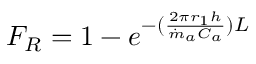Convert formula to latex. <formula><loc_0><loc_0><loc_500><loc_500>\begin{array} { r } { F _ { R } = 1 - e ^ { - ( \frac { 2 \pi r _ { 1 } h } { \dot { m } _ { a } C _ { a } } ) L } } \end{array}</formula> 